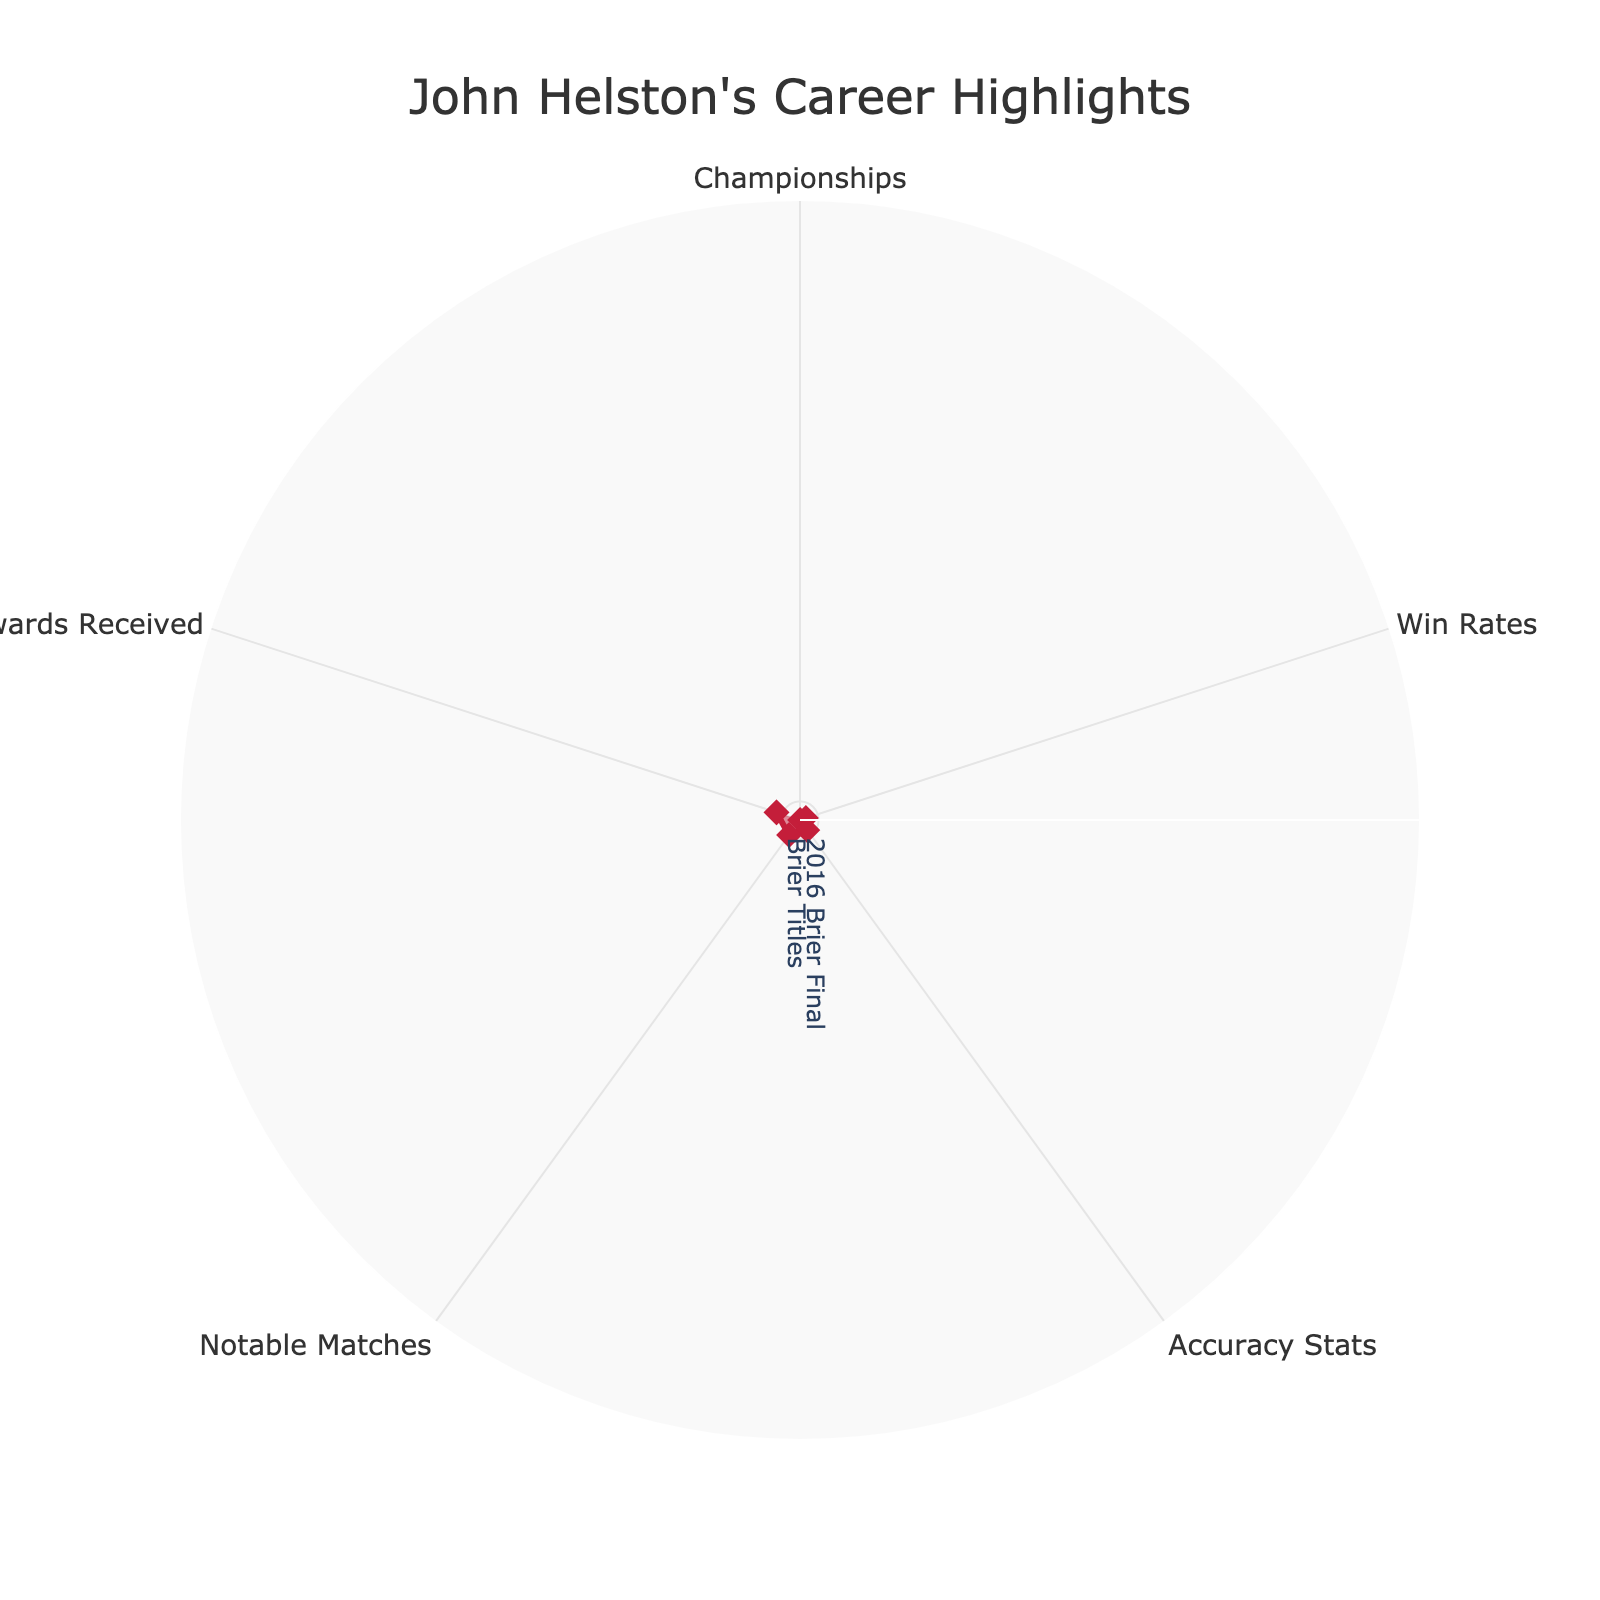What does the title of the chart indicate? The title of the chart indicates the overarching subject or focus of the radar chart. Look at the top center of the chart to find the title text.
Answer: John Helston's Career Highlights What are the different categories represented in this radar chart? The different categories are the labels on the perimeter of the radar chart. Identifying each one helps in understanding the various aspects of John Helston's career being evaluated.
Answer: Championships, Win Rates, Accuracy Stats, Notable Matches, Awards Received Which category has the lowest value in John Helston's Career Highlights? To determine the lowest value, examine the data points around the perimeter and identify which one is closest to the center.
Answer: Olympic Medals What is the exact value for John Helston’s Brier Titles? Locate the data point labeled "Brier Titles" and read the numeric value displayed at that axis point.
Answer: 80 Between World Championships and Mixed Doubles, which category has a higher value? Compare the values of the two categories on the chart to determine which is greater. The value further from the center is higher.
Answer: World Championships How many categories have a value equal to or greater than 85? Count the number of categories whose values extend to the 85, or beyond, position on the radial axis.
Answer: 3 What is the range of the radial axis on the radar chart? The radial axis is the series of concentric circles in the chart, and the range is indicated by the outermost circle. Look for the highest and lowest values shown there.
Answer: 0 to 100 If the average accuracy stat is crucial, what is John Helston’s value for Accuracy Stats, and how does it compare to this average assuming it's 90%? Locate the value for "Accuracy Stats" and compare it directly with the given average of 90%. This involves seeing if the value is below, equal to, or above 90%.
Answer: 91%, which is above the average Which category represents the pinnacle of John Helston's notable matches? Identify the description under “Notable Matches” that characterizes a particularly significant event or outcome in his career.
Answer: 2020 Players’ Championship What unique award has John Helston received that is not recognized in other categories? Distinguish each award named and identify one that does not appear in the same manner across other categories, indicating it’s unique.
Answer: Order of Canada 